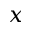<formula> <loc_0><loc_0><loc_500><loc_500>x</formula> 